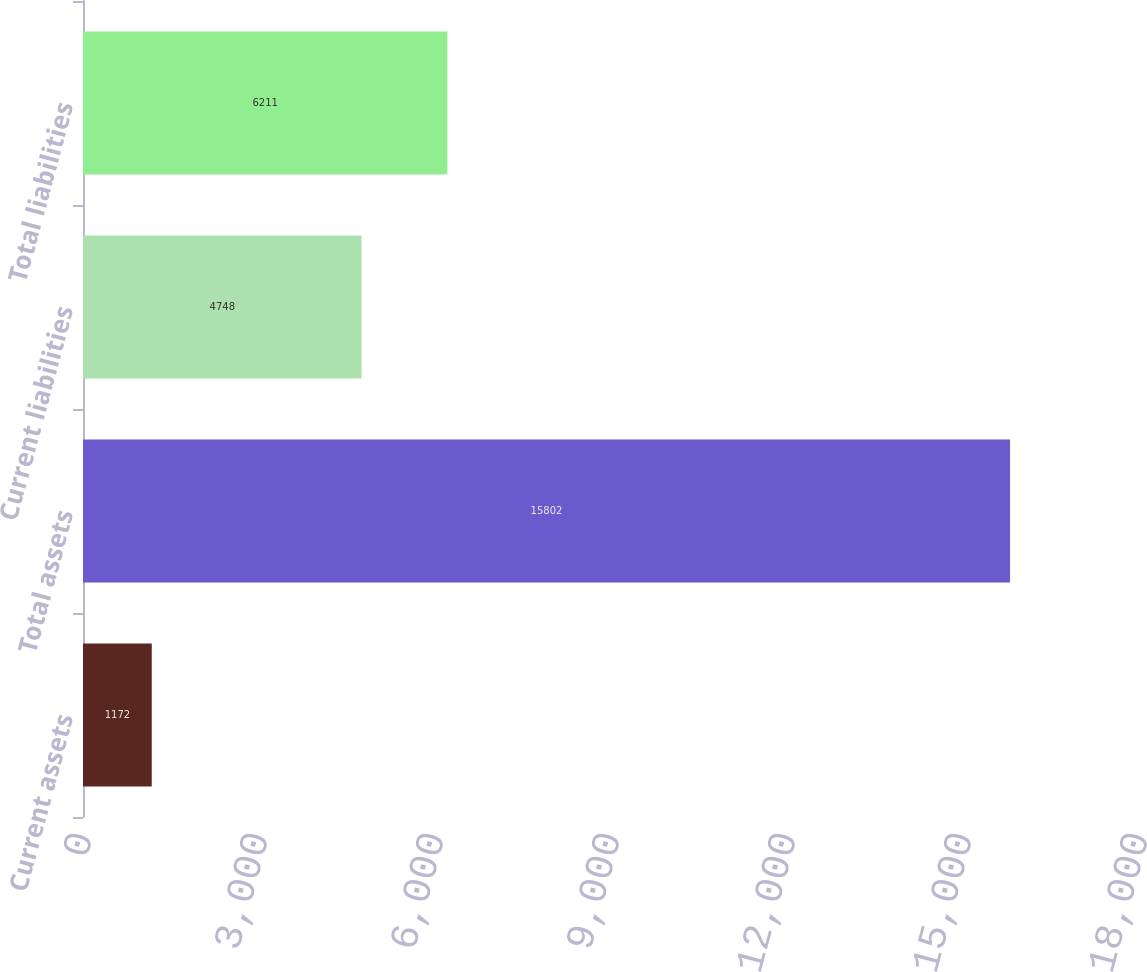<chart> <loc_0><loc_0><loc_500><loc_500><bar_chart><fcel>Current assets<fcel>Total assets<fcel>Current liabilities<fcel>Total liabilities<nl><fcel>1172<fcel>15802<fcel>4748<fcel>6211<nl></chart> 